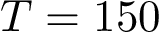<formula> <loc_0><loc_0><loc_500><loc_500>T = 1 5 0</formula> 